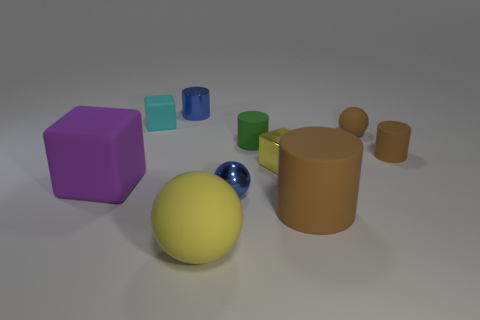Subtract 1 cylinders. How many cylinders are left? 3 Subtract all cylinders. How many objects are left? 6 Add 2 blocks. How many blocks exist? 5 Subtract 0 brown blocks. How many objects are left? 10 Subtract all purple metallic things. Subtract all tiny brown matte things. How many objects are left? 8 Add 2 yellow spheres. How many yellow spheres are left? 3 